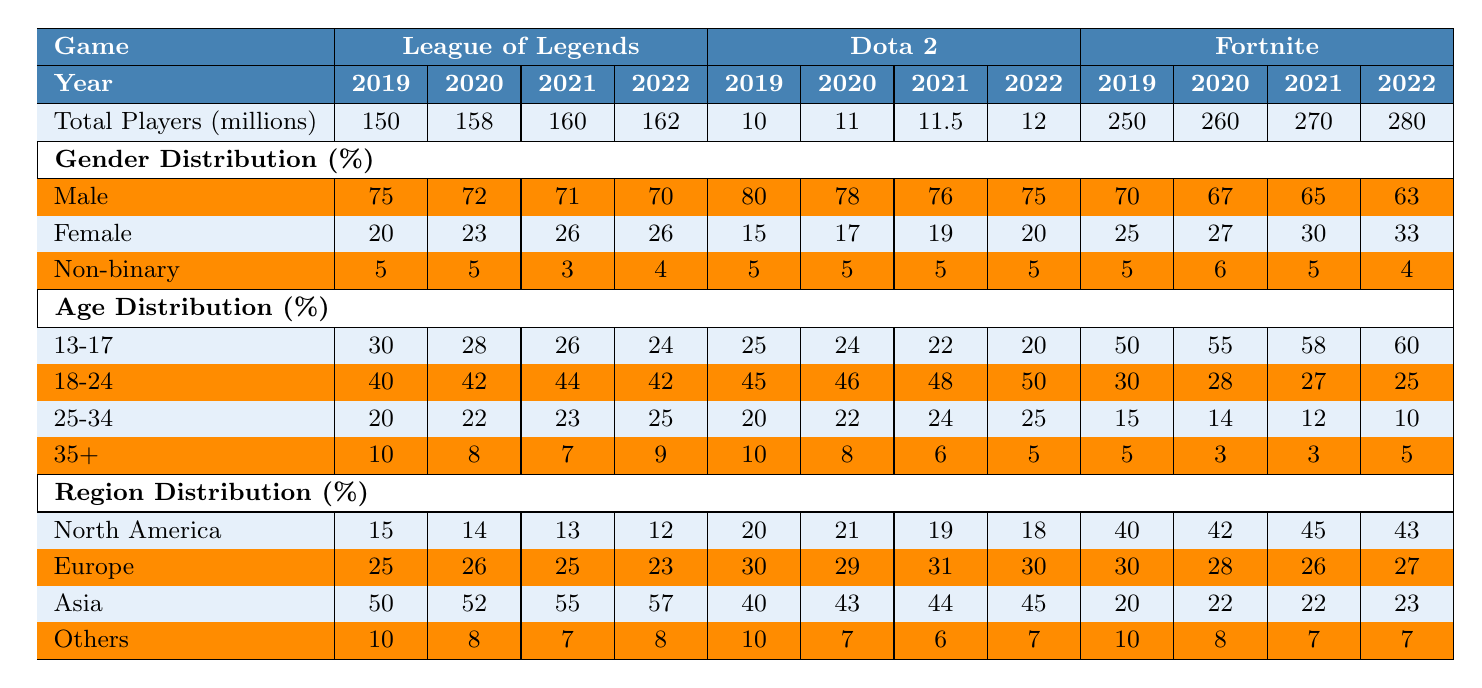What was the total number of players for Fortnite in 2021? In the table, under Fortnite, the total players for 2021 is listed as 270 million.
Answer: 270 million Which game had the highest percentage of male players in 2019? Looking at the gender distribution for 2019, Dota 2 had the highest percentage of male players at 80%.
Answer: Dota 2 What is the average percentage of female players for League of Legends from 2019 to 2022? Summing the percentages of female players for League of Legends from 2019 (20%), 2020 (23%), 2021 (26%), and 2022 (26%), we get 95%. Dividing by 4 (the number of years), we get an average of 23.75%.
Answer: 23.75% Is the percentage of players aged 13-17 for Fortnite increasing over the years? The percentages for Fortnite aged 13-17 are: 50% in 2019, 55% in 2020, 58% in 2021, and 60% in 2022. This shows an increasing trend each year.
Answer: Yes What was the total percentage of players from Asia across all games in 2022? The table shows Asia's percentages for League of Legends (57%), Dota 2 (45%), and Fortnite (23%) in 2022. Summing these gives 57 + 45 + 23 = 125%.
Answer: 125% Which demographic (age group) saw the largest decrease for Dota 2 from 2019 to 2022? For Dota 2, the age groups are: 13-17 (2019: 25%, 2022: 20%), 18-24 (2019: 45%, 2022: 50%), 25-34 (2019: 20%, 2022: 25%), and 35+ (2019: 10%, 2022: 5%). The 35+ age group saw a decrease of 5 percentage points.
Answer: 35+ What is the difference in total players between League of Legends in 2020 and Fortnite in 2021? League of Legends had 158 million players in 2020, while Fortnite had 270 million players in 2021. The difference is 270 - 158 = 112 million.
Answer: 112 million Is the percentage of female players for League of Legends higher or lower in 2022 than in 2019? The percentage of female players for League of Legends in 2019 was 20%, and in 2022 it was 26%. Since 26% is higher than 20%, the percentage increased.
Answer: Higher What is the most represented region in Dota 2 for 2023? In the region distribution for Dota 2 in 2023, Asia has the highest representation at 42%.
Answer: Asia Which year saw the lowest percentage of players aged 35+ for Fortnite? Looking at the age distribution for Fortnite, the percentage of players aged 35+ was 5% in both 2019 and 2020, and 3% in 2021 and 2022. Therefore, 2021 and 2022 saw the lowest percentage at 3%.
Answer: 2021 and 2022 